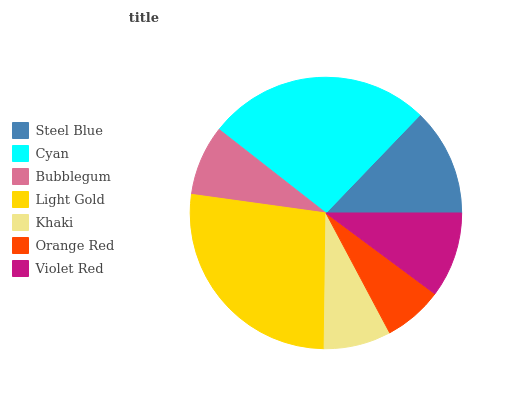Is Orange Red the minimum?
Answer yes or no. Yes. Is Light Gold the maximum?
Answer yes or no. Yes. Is Cyan the minimum?
Answer yes or no. No. Is Cyan the maximum?
Answer yes or no. No. Is Cyan greater than Steel Blue?
Answer yes or no. Yes. Is Steel Blue less than Cyan?
Answer yes or no. Yes. Is Steel Blue greater than Cyan?
Answer yes or no. No. Is Cyan less than Steel Blue?
Answer yes or no. No. Is Violet Red the high median?
Answer yes or no. Yes. Is Violet Red the low median?
Answer yes or no. Yes. Is Bubblegum the high median?
Answer yes or no. No. Is Orange Red the low median?
Answer yes or no. No. 